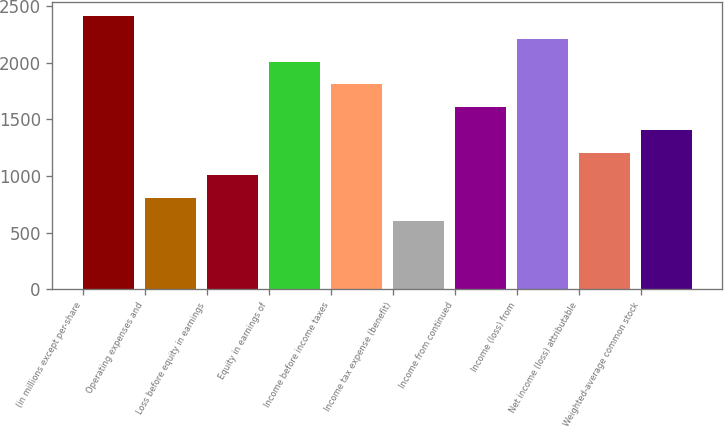Convert chart to OTSL. <chart><loc_0><loc_0><loc_500><loc_500><bar_chart><fcel>(in millions except per-share<fcel>Operating expenses and<fcel>Loss before equity in earnings<fcel>Equity in earnings of<fcel>Income before income taxes<fcel>Income tax expense (benefit)<fcel>Income from continued<fcel>Income (loss) from<fcel>Net income (loss) attributable<fcel>Weighted-average common stock<nl><fcel>2414.24<fcel>805.12<fcel>1006.26<fcel>2011.96<fcel>1810.82<fcel>603.98<fcel>1609.68<fcel>2213.1<fcel>1207.4<fcel>1408.54<nl></chart> 